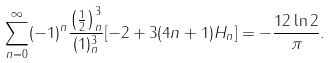<formula> <loc_0><loc_0><loc_500><loc_500>\sum _ { n = 0 } ^ { \infty } ( - 1 ) ^ { n } \frac { \left ( \frac { 1 } { 2 } \right ) _ { n } ^ { 3 } } { ( 1 ) _ { n } ^ { 3 } } [ - 2 + 3 ( 4 n + 1 ) H _ { n } ] = - \frac { 1 2 \ln 2 } { \pi } .</formula> 